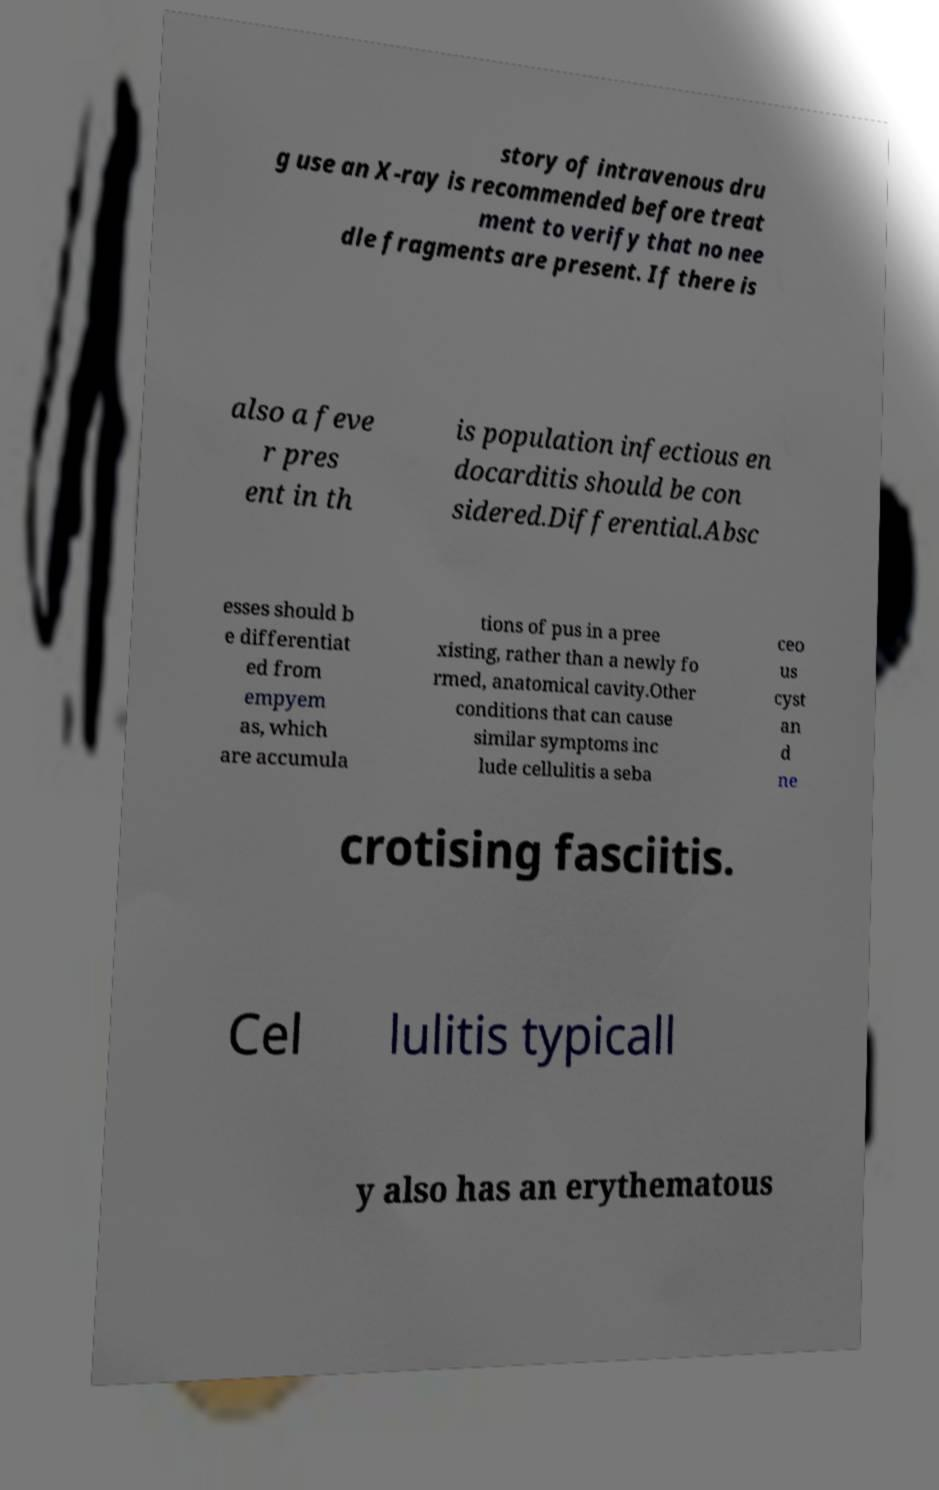Could you extract and type out the text from this image? story of intravenous dru g use an X-ray is recommended before treat ment to verify that no nee dle fragments are present. If there is also a feve r pres ent in th is population infectious en docarditis should be con sidered.Differential.Absc esses should b e differentiat ed from empyem as, which are accumula tions of pus in a pree xisting, rather than a newly fo rmed, anatomical cavity.Other conditions that can cause similar symptoms inc lude cellulitis a seba ceo us cyst an d ne crotising fasciitis. Cel lulitis typicall y also has an erythematous 